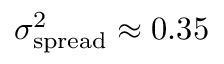Convert formula to latex. <formula><loc_0><loc_0><loc_500><loc_500>\sigma _ { s p r e a d } ^ { 2 } \approx 0 . 3 5</formula> 